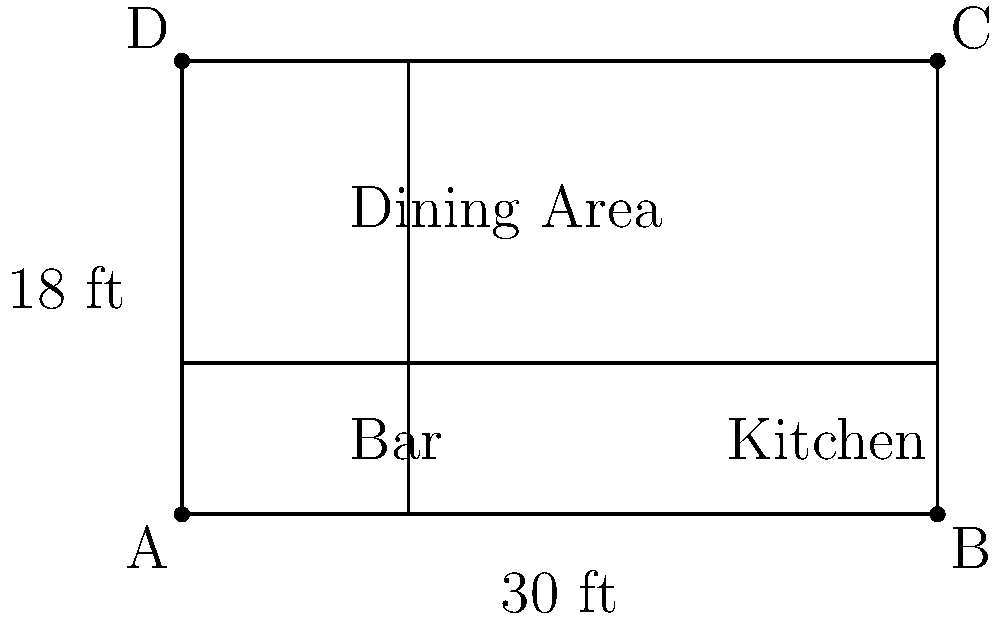Based on the floor plan of your restaurant shown above, estimate the total renovation cost if the average cost per square foot is $150. The dimensions are given in feet. To estimate the total renovation cost, we need to follow these steps:

1. Calculate the total area of the restaurant:
   * Length of the restaurant = 30 ft
   * Width of the restaurant = 18 ft
   * Total area = Length × Width
   * Total area = 30 ft × 18 ft = 540 sq ft

2. Calculate the cost per square foot:
   * Given average cost per square foot = $150

3. Calculate the total renovation cost:
   * Total cost = Total area × Cost per square foot
   * Total cost = 540 sq ft × $150/sq ft
   * Total cost = $81,000

Therefore, the estimated total renovation cost for your restaurant is $81,000.
Answer: $81,000 